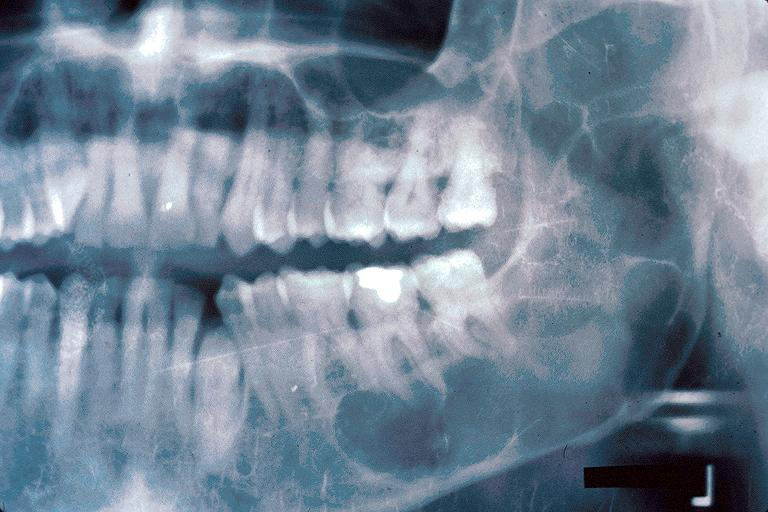where is this?
Answer the question using a single word or phrase. Oral 